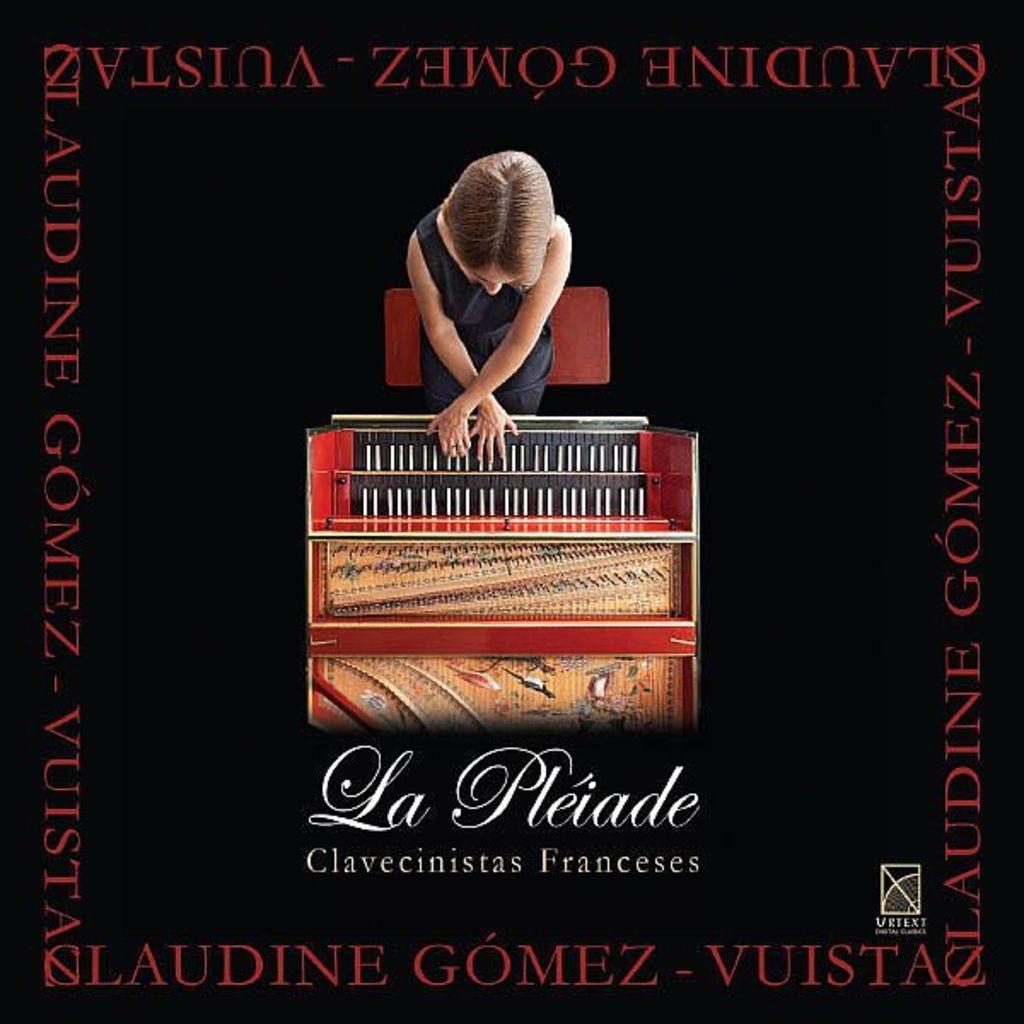Describe this image in one or two sentences. In this image we can see an edited image. 